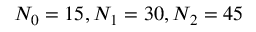Convert formula to latex. <formula><loc_0><loc_0><loc_500><loc_500>N _ { 0 } = 1 5 , N _ { 1 } = 3 0 , N _ { 2 } = 4 5</formula> 